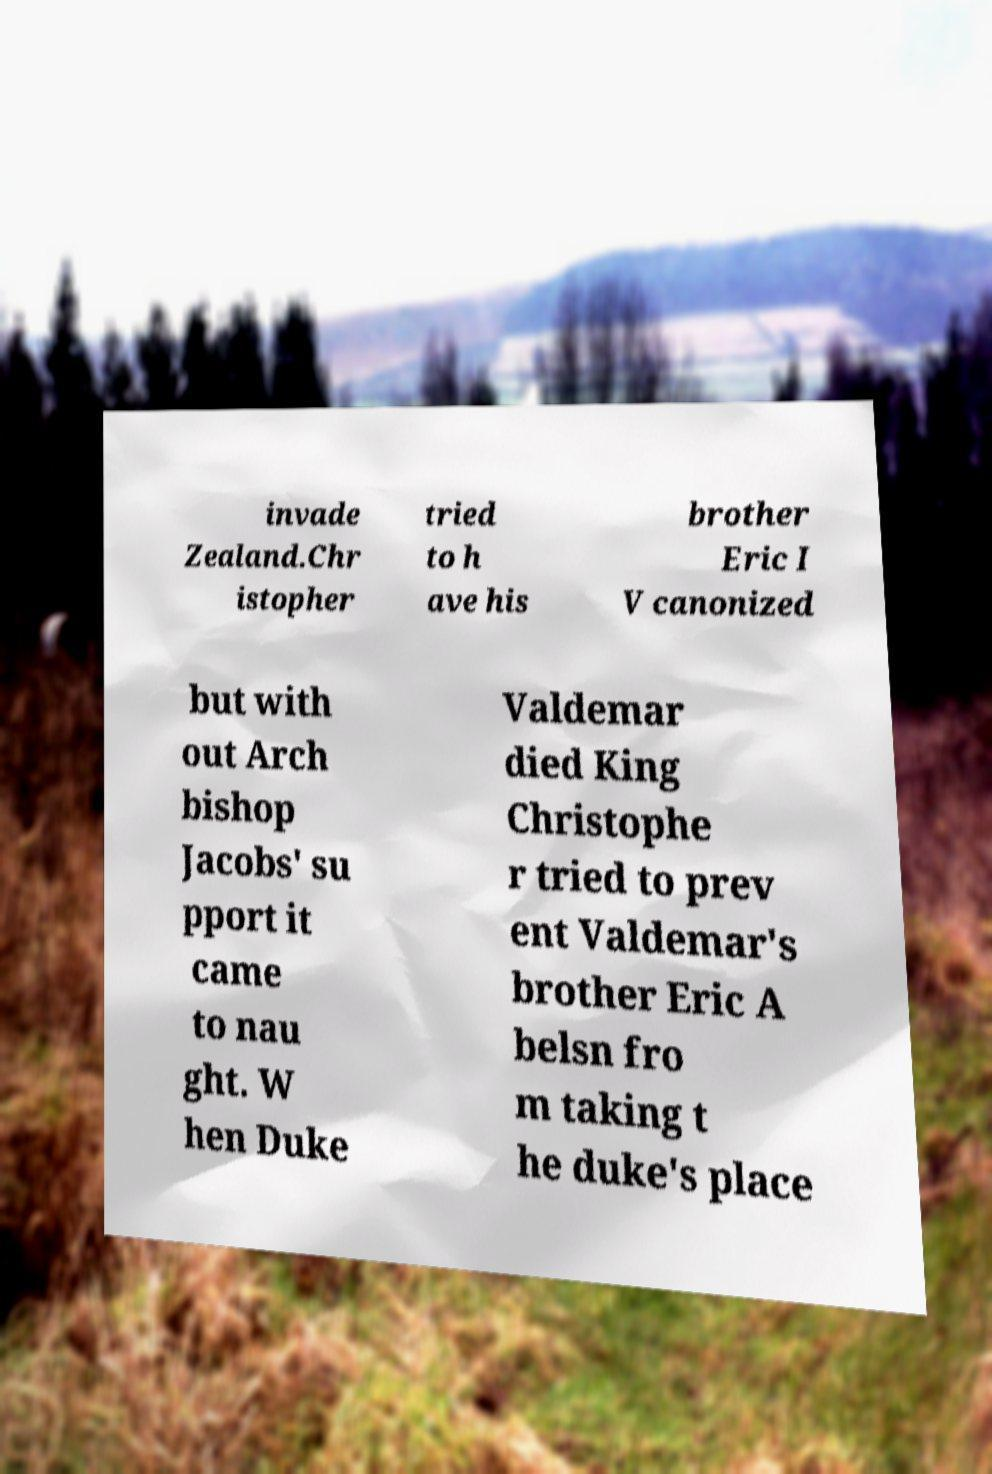I need the written content from this picture converted into text. Can you do that? invade Zealand.Chr istopher tried to h ave his brother Eric I V canonized but with out Arch bishop Jacobs' su pport it came to nau ght. W hen Duke Valdemar died King Christophe r tried to prev ent Valdemar's brother Eric A belsn fro m taking t he duke's place 